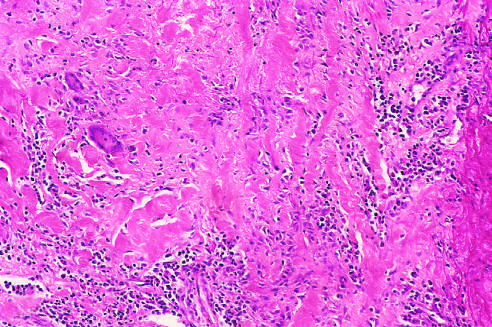s the histologic appearance in active takayasu aortitis illustrating destruction and fibrosis of the arterial media associated with mononuclear infiltrates and giant cells?
Answer the question using a single word or phrase. Yes 